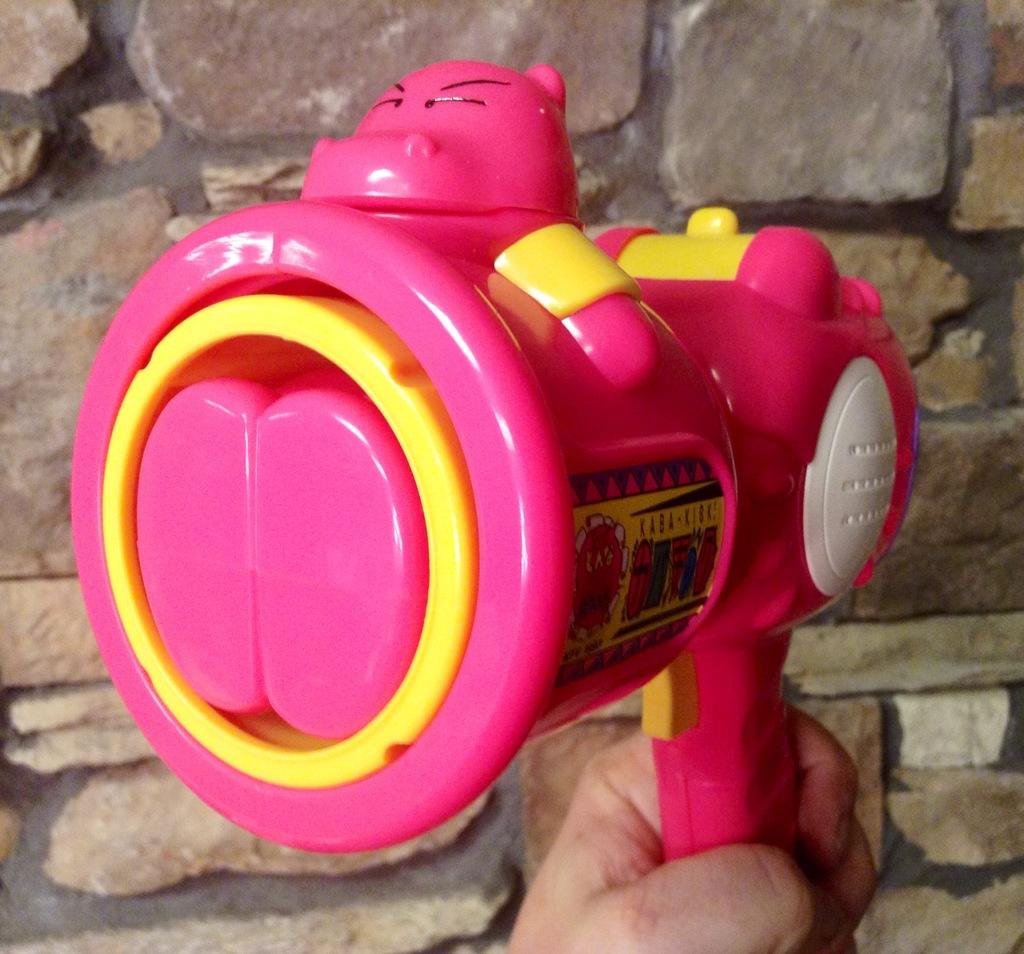What object is present in the image? There is a toy in the image. What colors can be seen on the toy? The toy is of pink and yellow color. How is the toy being held in the image? The toy is held by a person's hand. What can be seen in the background of the image? There is a wall in the background of the image. What type of news is being reported by the toy in the image? There is no news being reported in the image, as the toy is not a news source or reporter. 